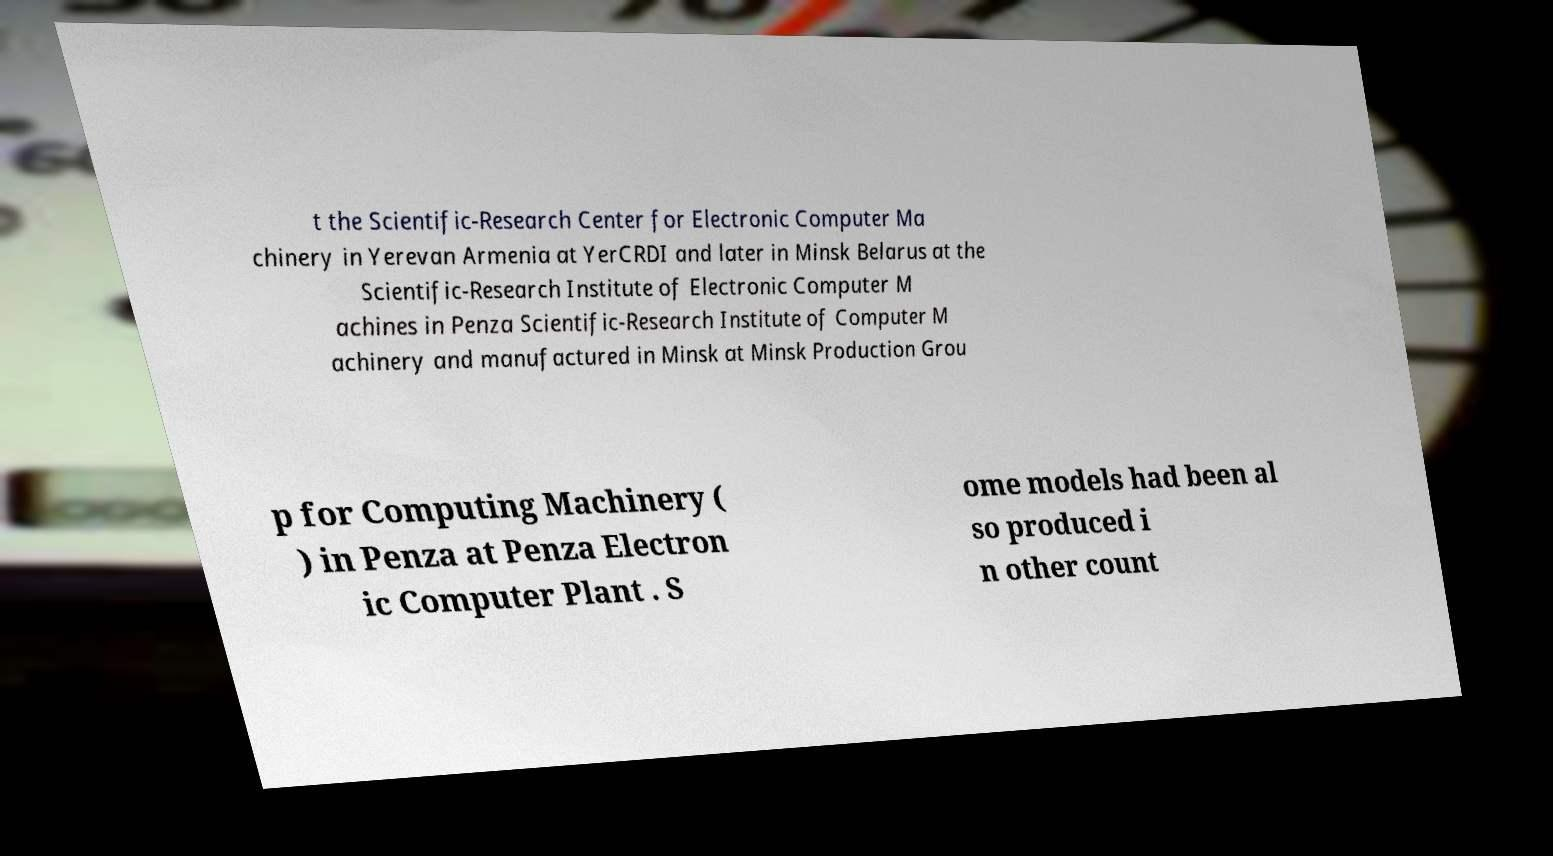Can you read and provide the text displayed in the image?This photo seems to have some interesting text. Can you extract and type it out for me? t the Scientific-Research Center for Electronic Computer Ma chinery in Yerevan Armenia at YerCRDI and later in Minsk Belarus at the Scientific-Research Institute of Electronic Computer M achines in Penza Scientific-Research Institute of Computer M achinery and manufactured in Minsk at Minsk Production Grou p for Computing Machinery ( ) in Penza at Penza Electron ic Computer Plant . S ome models had been al so produced i n other count 